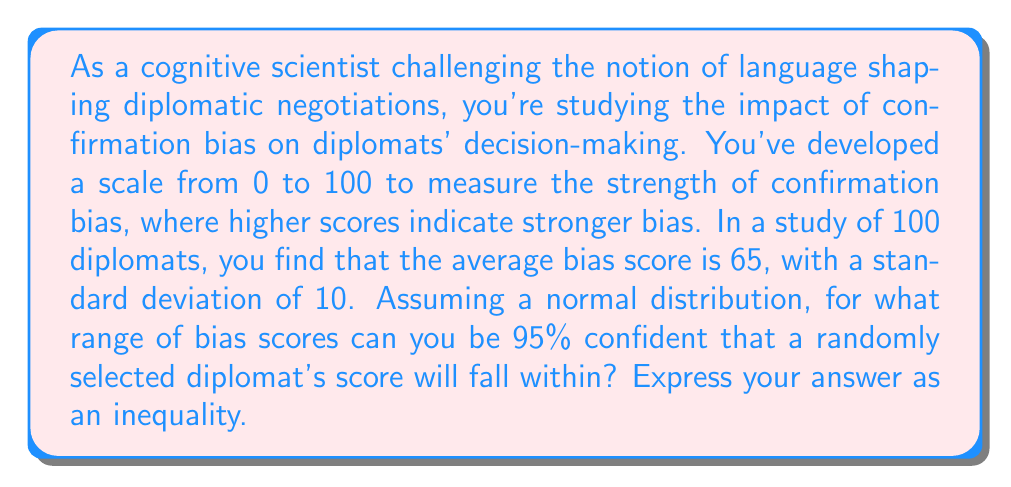What is the answer to this math problem? To solve this problem, we'll use the empirical rule (68-95-99.7 rule) for normal distributions. The 95% confidence interval is represented by two standard deviations on either side of the mean.

Given:
- Mean (μ) = 65
- Standard deviation (σ) = 10
- Confidence level = 95% (corresponding to ±2σ)

Steps:
1. Calculate the lower bound:
   Lower bound = μ - 2σ = 65 - 2(10) = 65 - 20 = 45

2. Calculate the upper bound:
   Upper bound = μ + 2σ = 65 + 2(10) = 65 + 20 = 85

3. Express the range as an inequality:
   $$ 45 < x < 85 $$
   where x represents a randomly selected diplomat's bias score.

This inequality states that we can be 95% confident that a randomly selected diplomat's confirmation bias score will fall between 45 and 85 on the scale.
Answer: $$ 45 < x < 85 $$
where x represents a randomly selected diplomat's confirmation bias score. 